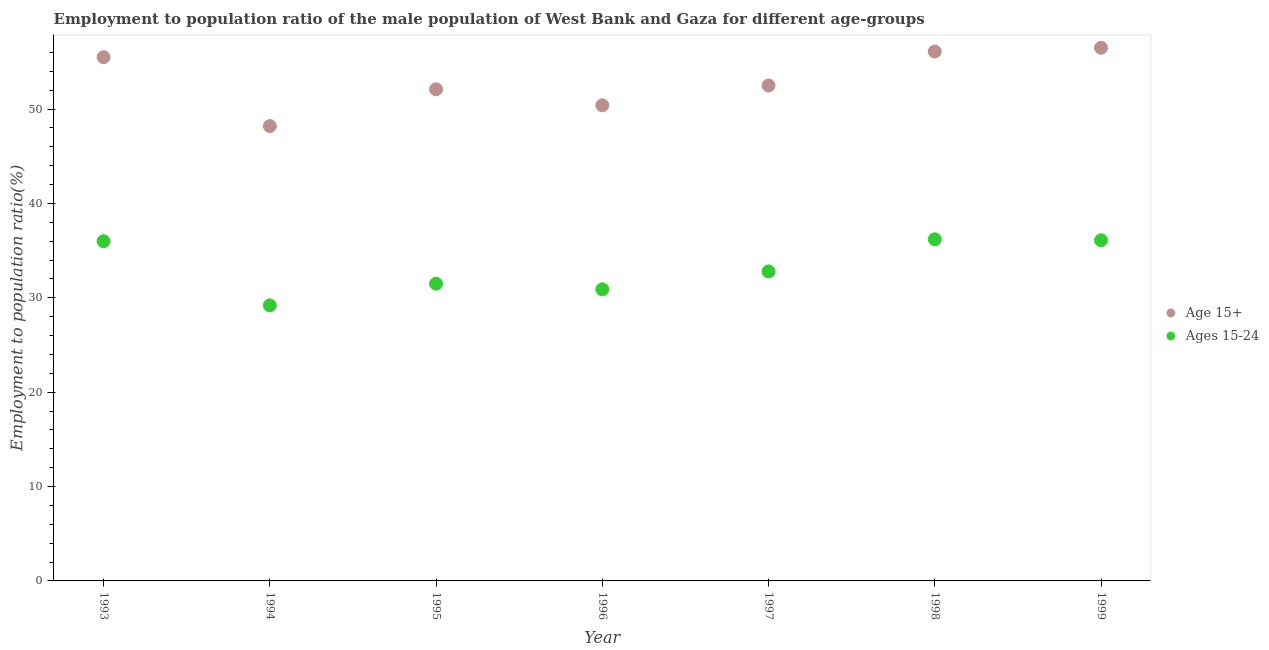What is the employment to population ratio(age 15-24) in 1996?
Provide a short and direct response. 30.9. Across all years, what is the maximum employment to population ratio(age 15+)?
Keep it short and to the point. 56.5. Across all years, what is the minimum employment to population ratio(age 15-24)?
Your answer should be compact. 29.2. In which year was the employment to population ratio(age 15+) maximum?
Give a very brief answer. 1999. In which year was the employment to population ratio(age 15-24) minimum?
Ensure brevity in your answer.  1994. What is the total employment to population ratio(age 15+) in the graph?
Provide a short and direct response. 371.3. What is the difference between the employment to population ratio(age 15-24) in 1996 and that in 1997?
Provide a succinct answer. -1.9. What is the difference between the employment to population ratio(age 15-24) in 1994 and the employment to population ratio(age 15+) in 1999?
Offer a terse response. -27.3. What is the average employment to population ratio(age 15+) per year?
Ensure brevity in your answer.  53.04. In the year 1998, what is the difference between the employment to population ratio(age 15-24) and employment to population ratio(age 15+)?
Keep it short and to the point. -19.9. What is the ratio of the employment to population ratio(age 15-24) in 1993 to that in 1997?
Offer a terse response. 1.1. Is the employment to population ratio(age 15-24) in 1996 less than that in 1997?
Your answer should be compact. Yes. What is the difference between the highest and the second highest employment to population ratio(age 15+)?
Give a very brief answer. 0.4. What is the difference between the highest and the lowest employment to population ratio(age 15+)?
Make the answer very short. 8.3. Is the employment to population ratio(age 15+) strictly greater than the employment to population ratio(age 15-24) over the years?
Give a very brief answer. Yes. Is the employment to population ratio(age 15-24) strictly less than the employment to population ratio(age 15+) over the years?
Offer a very short reply. Yes. How many dotlines are there?
Keep it short and to the point. 2. How many years are there in the graph?
Provide a short and direct response. 7. Are the values on the major ticks of Y-axis written in scientific E-notation?
Provide a succinct answer. No. Does the graph contain any zero values?
Your answer should be compact. No. Does the graph contain grids?
Provide a short and direct response. No. Where does the legend appear in the graph?
Ensure brevity in your answer.  Center right. How many legend labels are there?
Your answer should be compact. 2. What is the title of the graph?
Provide a succinct answer. Employment to population ratio of the male population of West Bank and Gaza for different age-groups. What is the label or title of the X-axis?
Offer a terse response. Year. What is the label or title of the Y-axis?
Give a very brief answer. Employment to population ratio(%). What is the Employment to population ratio(%) in Age 15+ in 1993?
Make the answer very short. 55.5. What is the Employment to population ratio(%) of Ages 15-24 in 1993?
Offer a terse response. 36. What is the Employment to population ratio(%) of Age 15+ in 1994?
Make the answer very short. 48.2. What is the Employment to population ratio(%) in Ages 15-24 in 1994?
Your answer should be very brief. 29.2. What is the Employment to population ratio(%) in Age 15+ in 1995?
Provide a succinct answer. 52.1. What is the Employment to population ratio(%) of Ages 15-24 in 1995?
Provide a short and direct response. 31.5. What is the Employment to population ratio(%) of Age 15+ in 1996?
Provide a succinct answer. 50.4. What is the Employment to population ratio(%) of Ages 15-24 in 1996?
Keep it short and to the point. 30.9. What is the Employment to population ratio(%) in Age 15+ in 1997?
Offer a terse response. 52.5. What is the Employment to population ratio(%) of Ages 15-24 in 1997?
Give a very brief answer. 32.8. What is the Employment to population ratio(%) in Age 15+ in 1998?
Give a very brief answer. 56.1. What is the Employment to population ratio(%) in Ages 15-24 in 1998?
Give a very brief answer. 36.2. What is the Employment to population ratio(%) in Age 15+ in 1999?
Provide a succinct answer. 56.5. What is the Employment to population ratio(%) of Ages 15-24 in 1999?
Keep it short and to the point. 36.1. Across all years, what is the maximum Employment to population ratio(%) of Age 15+?
Keep it short and to the point. 56.5. Across all years, what is the maximum Employment to population ratio(%) in Ages 15-24?
Provide a succinct answer. 36.2. Across all years, what is the minimum Employment to population ratio(%) of Age 15+?
Keep it short and to the point. 48.2. Across all years, what is the minimum Employment to population ratio(%) of Ages 15-24?
Keep it short and to the point. 29.2. What is the total Employment to population ratio(%) in Age 15+ in the graph?
Your answer should be very brief. 371.3. What is the total Employment to population ratio(%) in Ages 15-24 in the graph?
Provide a succinct answer. 232.7. What is the difference between the Employment to population ratio(%) of Age 15+ in 1993 and that in 1994?
Ensure brevity in your answer.  7.3. What is the difference between the Employment to population ratio(%) in Ages 15-24 in 1993 and that in 1994?
Provide a succinct answer. 6.8. What is the difference between the Employment to population ratio(%) in Ages 15-24 in 1993 and that in 1995?
Your response must be concise. 4.5. What is the difference between the Employment to population ratio(%) of Age 15+ in 1993 and that in 1996?
Give a very brief answer. 5.1. What is the difference between the Employment to population ratio(%) in Ages 15-24 in 1993 and that in 1996?
Give a very brief answer. 5.1. What is the difference between the Employment to population ratio(%) in Ages 15-24 in 1993 and that in 1997?
Ensure brevity in your answer.  3.2. What is the difference between the Employment to population ratio(%) in Age 15+ in 1993 and that in 1999?
Ensure brevity in your answer.  -1. What is the difference between the Employment to population ratio(%) of Age 15+ in 1994 and that in 1995?
Offer a very short reply. -3.9. What is the difference between the Employment to population ratio(%) of Ages 15-24 in 1994 and that in 1996?
Your answer should be compact. -1.7. What is the difference between the Employment to population ratio(%) of Age 15+ in 1994 and that in 1997?
Provide a short and direct response. -4.3. What is the difference between the Employment to population ratio(%) in Ages 15-24 in 1994 and that in 1997?
Your answer should be very brief. -3.6. What is the difference between the Employment to population ratio(%) in Ages 15-24 in 1994 and that in 1999?
Ensure brevity in your answer.  -6.9. What is the difference between the Employment to population ratio(%) of Ages 15-24 in 1995 and that in 1997?
Your response must be concise. -1.3. What is the difference between the Employment to population ratio(%) in Age 15+ in 1995 and that in 1998?
Your answer should be very brief. -4. What is the difference between the Employment to population ratio(%) of Ages 15-24 in 1995 and that in 1999?
Provide a succinct answer. -4.6. What is the difference between the Employment to population ratio(%) of Age 15+ in 1996 and that in 1998?
Your response must be concise. -5.7. What is the difference between the Employment to population ratio(%) in Ages 15-24 in 1996 and that in 1999?
Make the answer very short. -5.2. What is the difference between the Employment to population ratio(%) in Age 15+ in 1997 and that in 1999?
Your answer should be compact. -4. What is the difference between the Employment to population ratio(%) in Age 15+ in 1993 and the Employment to population ratio(%) in Ages 15-24 in 1994?
Ensure brevity in your answer.  26.3. What is the difference between the Employment to population ratio(%) of Age 15+ in 1993 and the Employment to population ratio(%) of Ages 15-24 in 1996?
Give a very brief answer. 24.6. What is the difference between the Employment to population ratio(%) in Age 15+ in 1993 and the Employment to population ratio(%) in Ages 15-24 in 1997?
Your response must be concise. 22.7. What is the difference between the Employment to population ratio(%) in Age 15+ in 1993 and the Employment to population ratio(%) in Ages 15-24 in 1998?
Provide a short and direct response. 19.3. What is the difference between the Employment to population ratio(%) in Age 15+ in 1994 and the Employment to population ratio(%) in Ages 15-24 in 1995?
Make the answer very short. 16.7. What is the difference between the Employment to population ratio(%) of Age 15+ in 1994 and the Employment to population ratio(%) of Ages 15-24 in 1996?
Ensure brevity in your answer.  17.3. What is the difference between the Employment to population ratio(%) of Age 15+ in 1994 and the Employment to population ratio(%) of Ages 15-24 in 1997?
Offer a very short reply. 15.4. What is the difference between the Employment to population ratio(%) of Age 15+ in 1994 and the Employment to population ratio(%) of Ages 15-24 in 1998?
Your answer should be very brief. 12. What is the difference between the Employment to population ratio(%) of Age 15+ in 1995 and the Employment to population ratio(%) of Ages 15-24 in 1996?
Provide a succinct answer. 21.2. What is the difference between the Employment to population ratio(%) in Age 15+ in 1995 and the Employment to population ratio(%) in Ages 15-24 in 1997?
Give a very brief answer. 19.3. What is the difference between the Employment to population ratio(%) of Age 15+ in 1995 and the Employment to population ratio(%) of Ages 15-24 in 1998?
Offer a terse response. 15.9. What is the difference between the Employment to population ratio(%) of Age 15+ in 1995 and the Employment to population ratio(%) of Ages 15-24 in 1999?
Your response must be concise. 16. What is the difference between the Employment to population ratio(%) in Age 15+ in 1996 and the Employment to population ratio(%) in Ages 15-24 in 1999?
Give a very brief answer. 14.3. What is the difference between the Employment to population ratio(%) in Age 15+ in 1997 and the Employment to population ratio(%) in Ages 15-24 in 1998?
Your response must be concise. 16.3. What is the difference between the Employment to population ratio(%) in Age 15+ in 1997 and the Employment to population ratio(%) in Ages 15-24 in 1999?
Your answer should be very brief. 16.4. What is the difference between the Employment to population ratio(%) in Age 15+ in 1998 and the Employment to population ratio(%) in Ages 15-24 in 1999?
Provide a succinct answer. 20. What is the average Employment to population ratio(%) of Age 15+ per year?
Provide a succinct answer. 53.04. What is the average Employment to population ratio(%) of Ages 15-24 per year?
Provide a short and direct response. 33.24. In the year 1995, what is the difference between the Employment to population ratio(%) in Age 15+ and Employment to population ratio(%) in Ages 15-24?
Offer a very short reply. 20.6. In the year 1996, what is the difference between the Employment to population ratio(%) in Age 15+ and Employment to population ratio(%) in Ages 15-24?
Your response must be concise. 19.5. In the year 1997, what is the difference between the Employment to population ratio(%) in Age 15+ and Employment to population ratio(%) in Ages 15-24?
Your answer should be very brief. 19.7. In the year 1998, what is the difference between the Employment to population ratio(%) of Age 15+ and Employment to population ratio(%) of Ages 15-24?
Ensure brevity in your answer.  19.9. In the year 1999, what is the difference between the Employment to population ratio(%) of Age 15+ and Employment to population ratio(%) of Ages 15-24?
Provide a short and direct response. 20.4. What is the ratio of the Employment to population ratio(%) of Age 15+ in 1993 to that in 1994?
Offer a terse response. 1.15. What is the ratio of the Employment to population ratio(%) of Ages 15-24 in 1993 to that in 1994?
Your answer should be compact. 1.23. What is the ratio of the Employment to population ratio(%) of Age 15+ in 1993 to that in 1995?
Give a very brief answer. 1.07. What is the ratio of the Employment to population ratio(%) in Age 15+ in 1993 to that in 1996?
Your answer should be very brief. 1.1. What is the ratio of the Employment to population ratio(%) of Ages 15-24 in 1993 to that in 1996?
Give a very brief answer. 1.17. What is the ratio of the Employment to population ratio(%) of Age 15+ in 1993 to that in 1997?
Make the answer very short. 1.06. What is the ratio of the Employment to population ratio(%) in Ages 15-24 in 1993 to that in 1997?
Make the answer very short. 1.1. What is the ratio of the Employment to population ratio(%) of Age 15+ in 1993 to that in 1998?
Keep it short and to the point. 0.99. What is the ratio of the Employment to population ratio(%) of Ages 15-24 in 1993 to that in 1998?
Keep it short and to the point. 0.99. What is the ratio of the Employment to population ratio(%) in Age 15+ in 1993 to that in 1999?
Provide a succinct answer. 0.98. What is the ratio of the Employment to population ratio(%) in Age 15+ in 1994 to that in 1995?
Offer a terse response. 0.93. What is the ratio of the Employment to population ratio(%) of Ages 15-24 in 1994 to that in 1995?
Keep it short and to the point. 0.93. What is the ratio of the Employment to population ratio(%) in Age 15+ in 1994 to that in 1996?
Give a very brief answer. 0.96. What is the ratio of the Employment to population ratio(%) of Ages 15-24 in 1994 to that in 1996?
Give a very brief answer. 0.94. What is the ratio of the Employment to population ratio(%) in Age 15+ in 1994 to that in 1997?
Give a very brief answer. 0.92. What is the ratio of the Employment to population ratio(%) of Ages 15-24 in 1994 to that in 1997?
Provide a succinct answer. 0.89. What is the ratio of the Employment to population ratio(%) of Age 15+ in 1994 to that in 1998?
Offer a very short reply. 0.86. What is the ratio of the Employment to population ratio(%) of Ages 15-24 in 1994 to that in 1998?
Give a very brief answer. 0.81. What is the ratio of the Employment to population ratio(%) of Age 15+ in 1994 to that in 1999?
Make the answer very short. 0.85. What is the ratio of the Employment to population ratio(%) of Ages 15-24 in 1994 to that in 1999?
Offer a very short reply. 0.81. What is the ratio of the Employment to population ratio(%) in Age 15+ in 1995 to that in 1996?
Make the answer very short. 1.03. What is the ratio of the Employment to population ratio(%) in Ages 15-24 in 1995 to that in 1996?
Give a very brief answer. 1.02. What is the ratio of the Employment to population ratio(%) in Ages 15-24 in 1995 to that in 1997?
Make the answer very short. 0.96. What is the ratio of the Employment to population ratio(%) in Age 15+ in 1995 to that in 1998?
Your answer should be compact. 0.93. What is the ratio of the Employment to population ratio(%) of Ages 15-24 in 1995 to that in 1998?
Provide a succinct answer. 0.87. What is the ratio of the Employment to population ratio(%) of Age 15+ in 1995 to that in 1999?
Make the answer very short. 0.92. What is the ratio of the Employment to population ratio(%) of Ages 15-24 in 1995 to that in 1999?
Ensure brevity in your answer.  0.87. What is the ratio of the Employment to population ratio(%) in Age 15+ in 1996 to that in 1997?
Provide a short and direct response. 0.96. What is the ratio of the Employment to population ratio(%) in Ages 15-24 in 1996 to that in 1997?
Ensure brevity in your answer.  0.94. What is the ratio of the Employment to population ratio(%) in Age 15+ in 1996 to that in 1998?
Make the answer very short. 0.9. What is the ratio of the Employment to population ratio(%) in Ages 15-24 in 1996 to that in 1998?
Your answer should be very brief. 0.85. What is the ratio of the Employment to population ratio(%) in Age 15+ in 1996 to that in 1999?
Your answer should be very brief. 0.89. What is the ratio of the Employment to population ratio(%) in Ages 15-24 in 1996 to that in 1999?
Offer a very short reply. 0.86. What is the ratio of the Employment to population ratio(%) in Age 15+ in 1997 to that in 1998?
Your answer should be very brief. 0.94. What is the ratio of the Employment to population ratio(%) in Ages 15-24 in 1997 to that in 1998?
Your answer should be very brief. 0.91. What is the ratio of the Employment to population ratio(%) of Age 15+ in 1997 to that in 1999?
Provide a succinct answer. 0.93. What is the ratio of the Employment to population ratio(%) in Ages 15-24 in 1997 to that in 1999?
Keep it short and to the point. 0.91. What is the difference between the highest and the second highest Employment to population ratio(%) of Age 15+?
Provide a succinct answer. 0.4. What is the difference between the highest and the second highest Employment to population ratio(%) in Ages 15-24?
Offer a terse response. 0.1. What is the difference between the highest and the lowest Employment to population ratio(%) in Ages 15-24?
Keep it short and to the point. 7. 